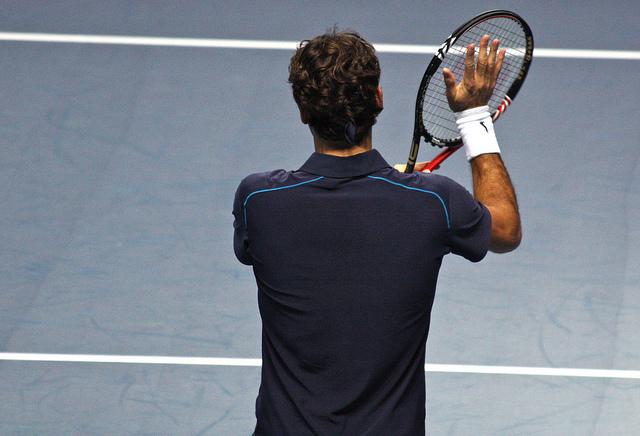What is the color of the wristband?
Short answer required. White. What sport is taking place?
Write a very short answer. Tennis. What two colors make up the shirt?
Write a very short answer. Black and blue. 